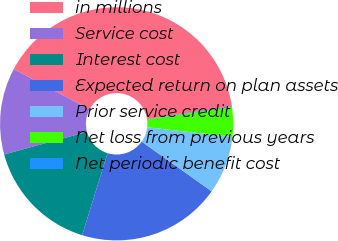<chart> <loc_0><loc_0><loc_500><loc_500><pie_chart><fcel>in millions<fcel>Service cost<fcel>Interest cost<fcel>Expected return on plan assets<fcel>Prior service credit<fcel>Net loss from previous years<fcel>Net periodic benefit cost<nl><fcel>39.79%<fcel>12.02%<fcel>15.99%<fcel>19.95%<fcel>8.05%<fcel>4.09%<fcel>0.12%<nl></chart> 